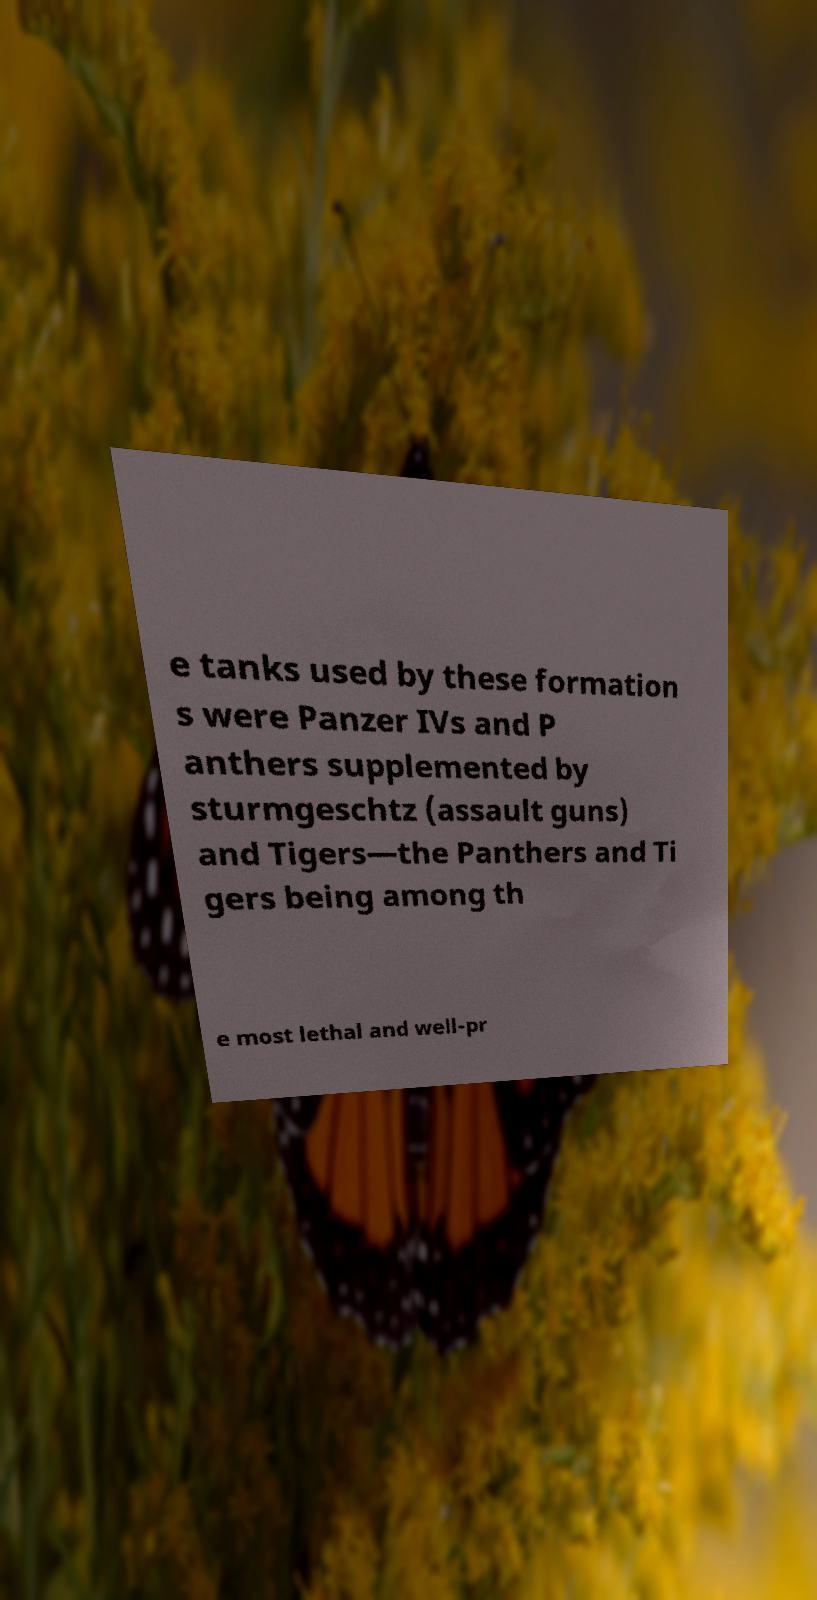Please read and relay the text visible in this image. What does it say? e tanks used by these formation s were Panzer IVs and P anthers supplemented by sturmgeschtz (assault guns) and Tigers—the Panthers and Ti gers being among th e most lethal and well-pr 